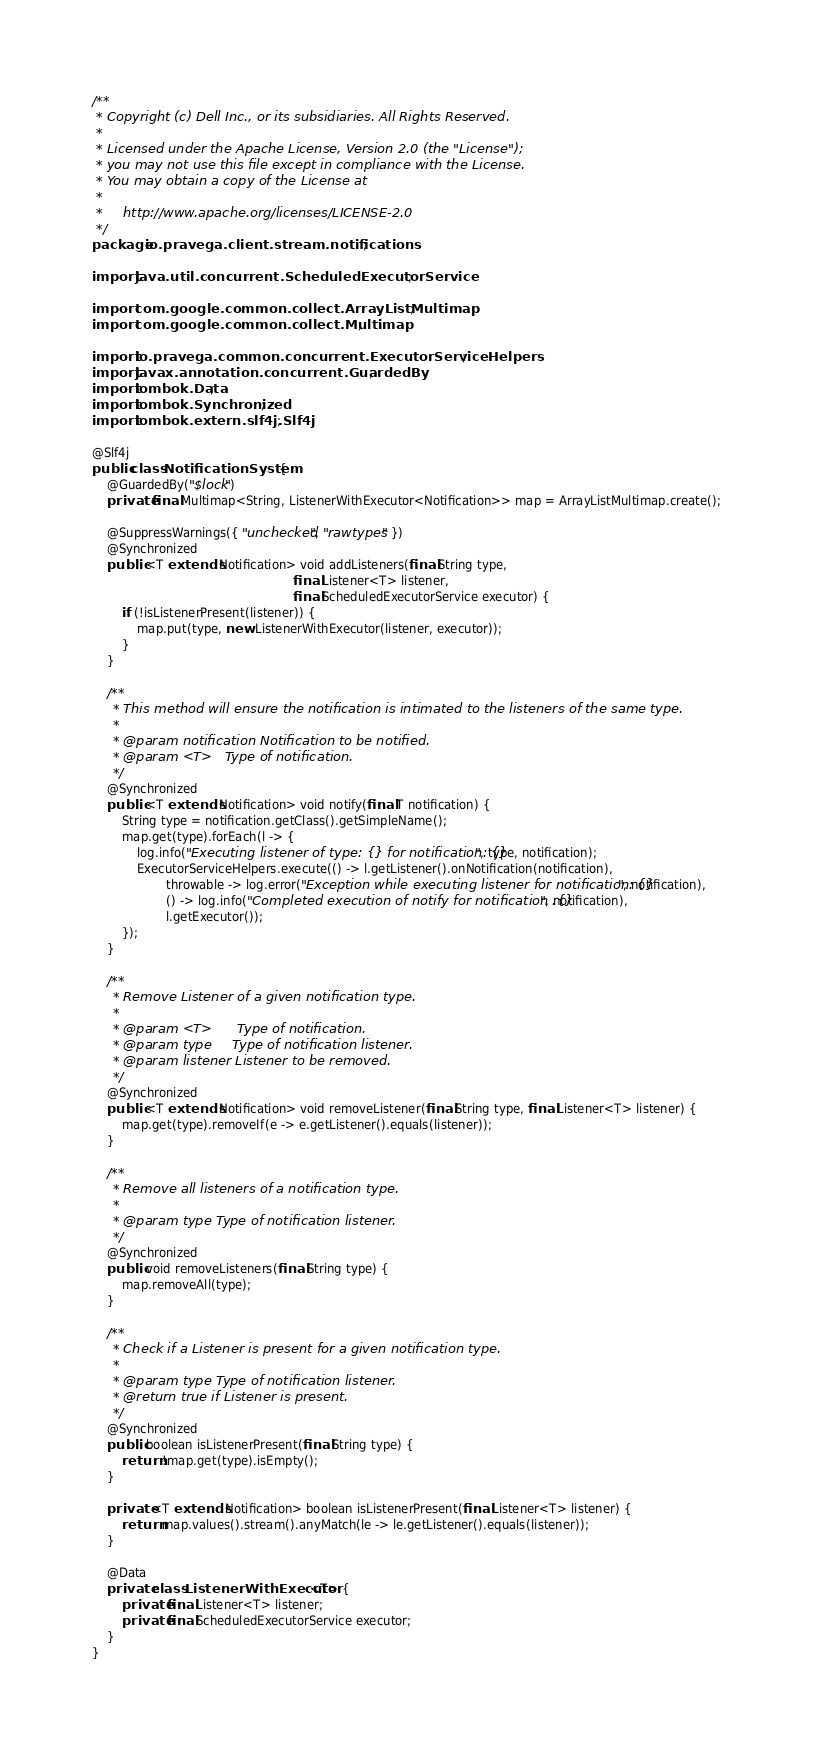Convert code to text. <code><loc_0><loc_0><loc_500><loc_500><_Java_>/**
 * Copyright (c) Dell Inc., or its subsidiaries. All Rights Reserved.
 *
 * Licensed under the Apache License, Version 2.0 (the "License");
 * you may not use this file except in compliance with the License.
 * You may obtain a copy of the License at
 *
 *     http://www.apache.org/licenses/LICENSE-2.0
 */
package io.pravega.client.stream.notifications;

import java.util.concurrent.ScheduledExecutorService;

import com.google.common.collect.ArrayListMultimap;
import com.google.common.collect.Multimap;

import io.pravega.common.concurrent.ExecutorServiceHelpers;
import javax.annotation.concurrent.GuardedBy;
import lombok.Data;
import lombok.Synchronized;
import lombok.extern.slf4j.Slf4j;

@Slf4j
public class NotificationSystem {
    @GuardedBy("$lock")
    private final Multimap<String, ListenerWithExecutor<Notification>> map = ArrayListMultimap.create();

    @SuppressWarnings({ "unchecked", "rawtypes" })
    @Synchronized
    public <T extends Notification> void addListeners(final String type,
                                                      final Listener<T> listener,
                                                      final ScheduledExecutorService executor) {
        if (!isListenerPresent(listener)) {
            map.put(type, new ListenerWithExecutor(listener, executor));
        }
    }

    /**
     * This method will ensure the notification is intimated to the listeners of the same type.
     *
     * @param notification Notification to be notified.
     * @param <T>   Type of notification.
     */
    @Synchronized
    public <T extends Notification> void notify(final T notification) {
        String type = notification.getClass().getSimpleName();
        map.get(type).forEach(l -> {
            log.info("Executing listener of type: {} for notification: {}", type, notification);
            ExecutorServiceHelpers.execute(() -> l.getListener().onNotification(notification),
                    throwable -> log.error("Exception while executing listener for notification: {}", notification),
                    () -> log.info("Completed execution of notify for notification :{}", notification),
                    l.getExecutor());
        });
    }

    /**
     * Remove Listener of a given notification type.
     *
     * @param <T>      Type of notification.
     * @param type     Type of notification listener.
     * @param listener Listener to be removed.
     */
    @Synchronized
    public <T extends Notification> void removeListener(final String type, final Listener<T> listener) {
        map.get(type).removeIf(e -> e.getListener().equals(listener));
    }

    /**
     * Remove all listeners of a notification type.
     *
     * @param type Type of notification listener.
     */
    @Synchronized
    public void removeListeners(final String type) {
        map.removeAll(type);
    }

    /**
     * Check if a Listener is present for a given notification type.
     *
     * @param type Type of notification listener.
     * @return true if Listener is present.
     */
    @Synchronized
    public boolean isListenerPresent(final String type) {
        return !map.get(type).isEmpty();
    }

    private <T extends Notification> boolean isListenerPresent(final Listener<T> listener) {
        return map.values().stream().anyMatch(le -> le.getListener().equals(listener));
    }

    @Data
    private class ListenerWithExecutor<T> {
        private final Listener<T> listener;
        private final ScheduledExecutorService executor;
    }
}
</code> 